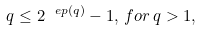<formula> <loc_0><loc_0><loc_500><loc_500>q \leq 2 ^ { \ e p ( q ) } - 1 , \, f o r \, q > 1 ,</formula> 